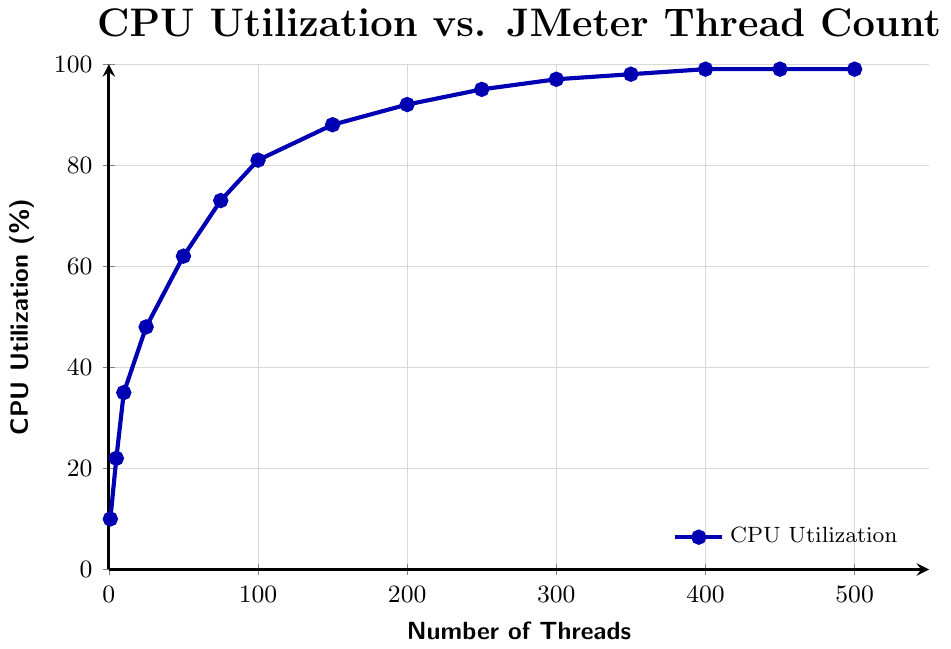What is the CPU utilization for 100 threads? Locate the point on the line chart where the number of threads is 100. The corresponding CPU utilization value is 81%.
Answer: 81% Does the CPU utilization reach 100% at any point in the chart? Observe that the highest CPU utilization value is 99%, which means it does not reach 100% at any point.
Answer: No At which number of threads does the CPU utilization first reach 95%? Follow the curve and note the number of threads when the CPU utilization first hits 95%, which is at 250 threads.
Answer: 250 How much does the CPU utilization increase between 10 and 100 threads? Find the CPU utilization at 10 threads (35%) and at 100 threads (81%). The difference between these values is 81% - 35% = 46%.
Answer: 46% Between 300 and 400 threads, by how much does the CPU utilization increase? Look at the CPU utilization at 300 threads (97%) and at 400 threads (99%). The increase is 99% - 97% = 2%.
Answer: 2% What is the general trend of CPU utilization as the number of threads increases from 1 to 500? Observe the overall pattern in the chart: CPU utilization increases rapidly at first and then starts to plateau after 300 threads.
Answer: Increases rapidly at first, then plateaus What is the CPU utilization for the highest number of threads shown in the chart? Look at the number of threads at 500, the corresponding CPU utilization reaches 99%.
Answer: 99% How much CPU utilization is observed at 75 threads, and how does it compare to 150 threads? Navigate to the points for 75 threads (73%) and 150 threads (88%). The CPU utilization at 150 threads is higher by 88% - 73% = 15%.
Answer: 15% What is the difference in CPU utilization between 1 and 5 threads? Locate the CPU utilization values for 1 thread (10%) and 5 threads (22%). The difference is 22% - 10% = 12%.
Answer: 12% Does the CPU utilization change significantly after reaching 400 threads? Look at the CPU utilization values for 400 (99%), 450 (99%), and 500 (99%) threads, noting that there is no significant change.
Answer: No 